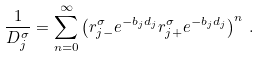<formula> <loc_0><loc_0><loc_500><loc_500>\frac { 1 } { D _ { j } ^ { \sigma } } = \sum _ { n = 0 } ^ { \infty } \left ( r _ { j - } ^ { \sigma } e ^ { - b _ { j } d _ { j } } r _ { j + } ^ { \sigma } e ^ { - b _ { j } d _ { j } } \right ) ^ { n } \, .</formula> 